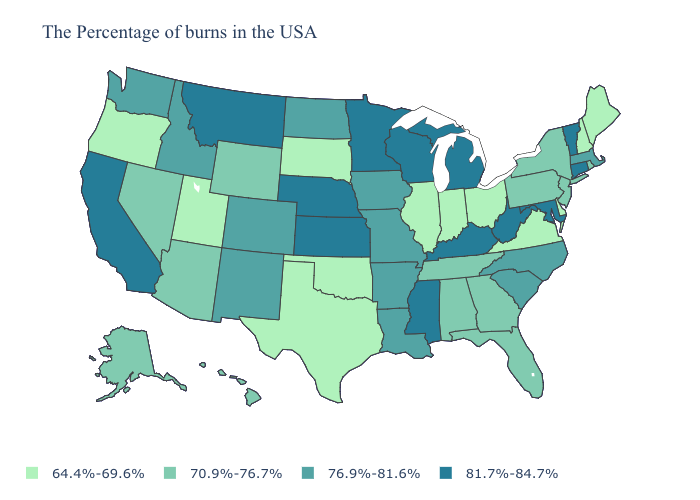What is the value of Delaware?
Answer briefly. 64.4%-69.6%. What is the lowest value in the Northeast?
Keep it brief. 64.4%-69.6%. How many symbols are there in the legend?
Quick response, please. 4. How many symbols are there in the legend?
Quick response, please. 4. Does Oregon have the lowest value in the West?
Answer briefly. Yes. Name the states that have a value in the range 76.9%-81.6%?
Keep it brief. Massachusetts, North Carolina, South Carolina, Louisiana, Missouri, Arkansas, Iowa, North Dakota, Colorado, New Mexico, Idaho, Washington. What is the value of Louisiana?
Write a very short answer. 76.9%-81.6%. Does the first symbol in the legend represent the smallest category?
Keep it brief. Yes. What is the highest value in the USA?
Quick response, please. 81.7%-84.7%. Name the states that have a value in the range 70.9%-76.7%?
Be succinct. Rhode Island, New York, New Jersey, Pennsylvania, Florida, Georgia, Alabama, Tennessee, Wyoming, Arizona, Nevada, Alaska, Hawaii. What is the highest value in the South ?
Answer briefly. 81.7%-84.7%. Among the states that border Wyoming , which have the highest value?
Write a very short answer. Nebraska, Montana. Name the states that have a value in the range 81.7%-84.7%?
Short answer required. Vermont, Connecticut, Maryland, West Virginia, Michigan, Kentucky, Wisconsin, Mississippi, Minnesota, Kansas, Nebraska, Montana, California. Which states have the lowest value in the MidWest?
Write a very short answer. Ohio, Indiana, Illinois, South Dakota. 